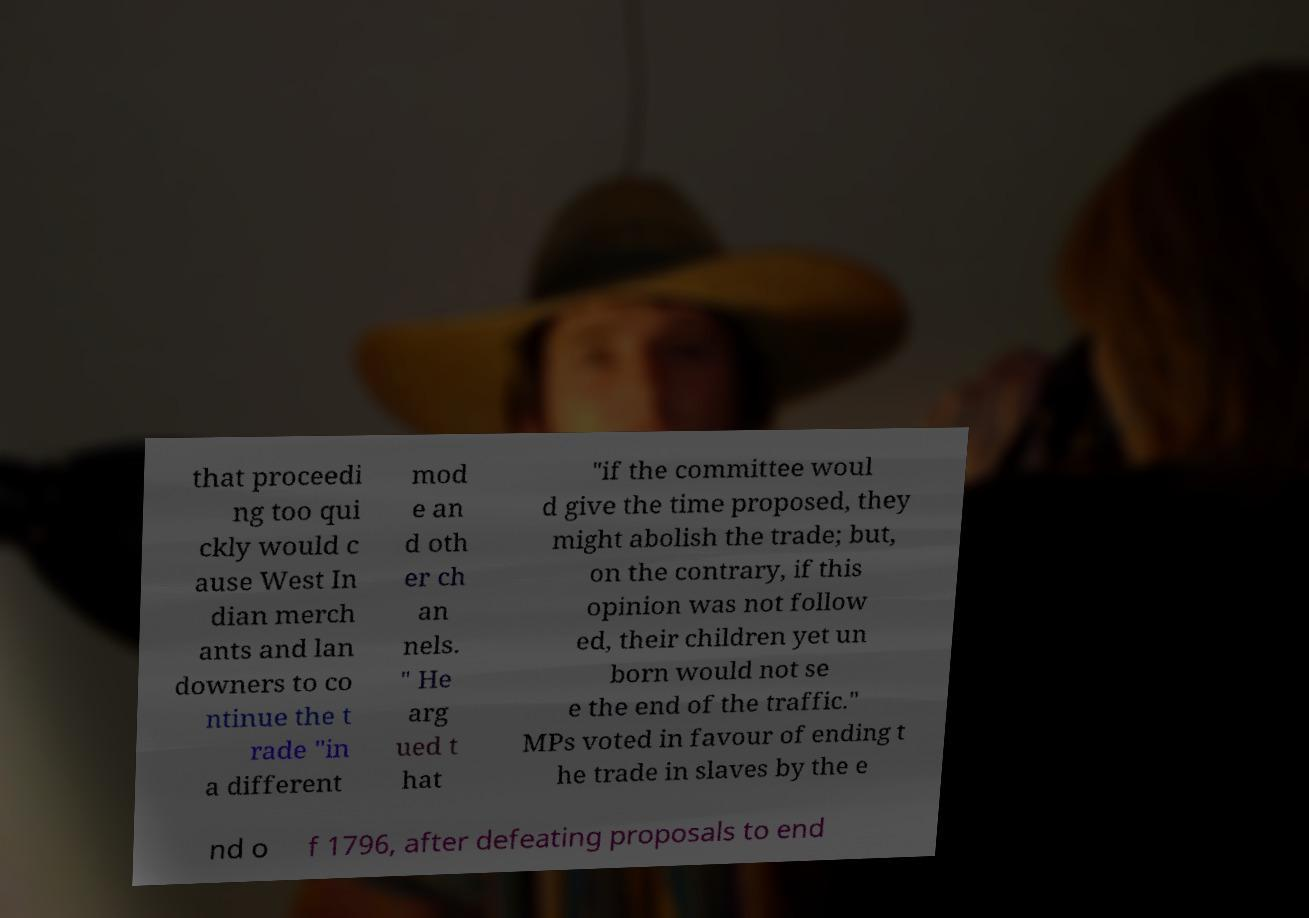What messages or text are displayed in this image? I need them in a readable, typed format. that proceedi ng too qui ckly would c ause West In dian merch ants and lan downers to co ntinue the t rade "in a different mod e an d oth er ch an nels. " He arg ued t hat "if the committee woul d give the time proposed, they might abolish the trade; but, on the contrary, if this opinion was not follow ed, their children yet un born would not se e the end of the traffic." MPs voted in favour of ending t he trade in slaves by the e nd o f 1796, after defeating proposals to end 